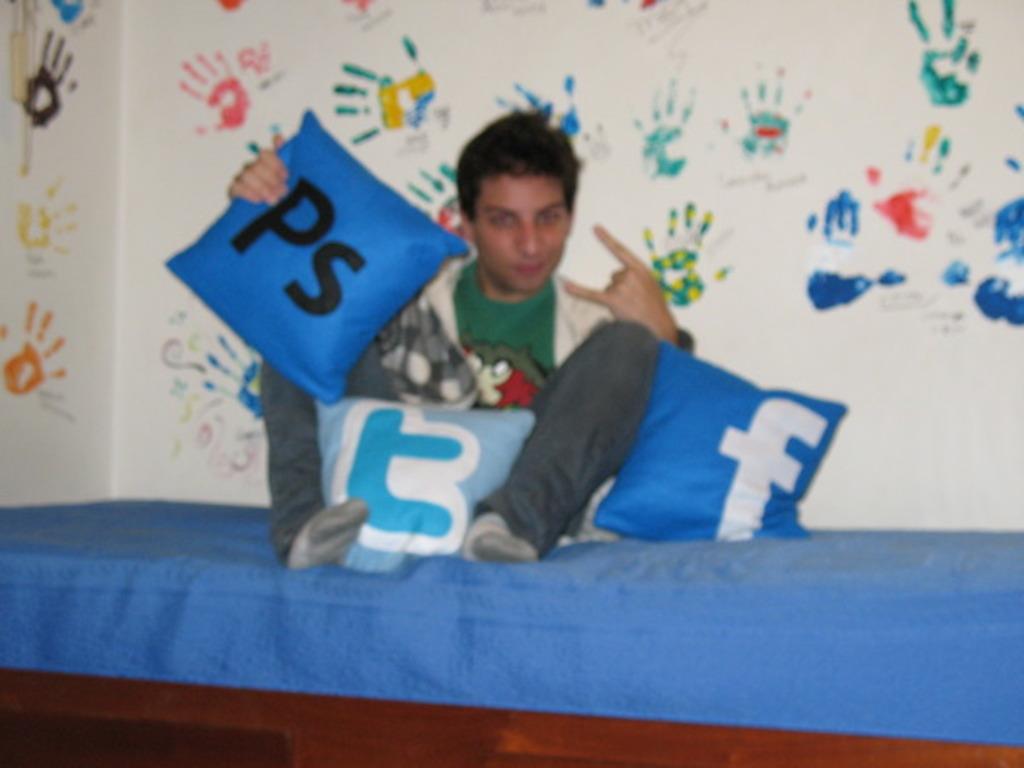What letters are on the blue pillow he is holding?
Your answer should be very brief. Ps. 